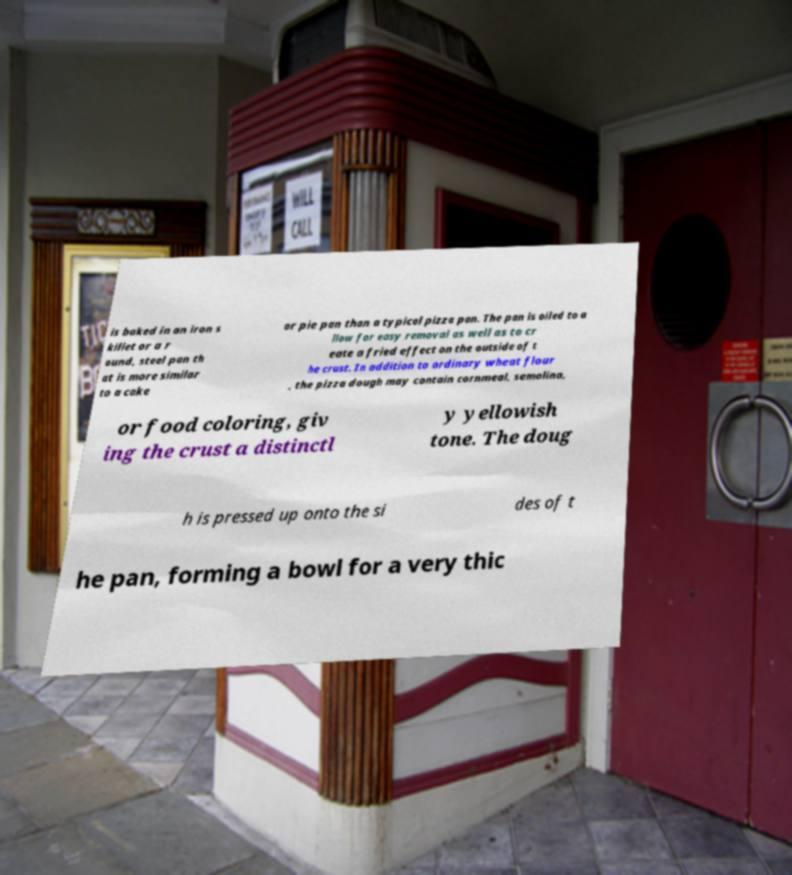Please identify and transcribe the text found in this image. is baked in an iron s killet or a r ound, steel pan th at is more similar to a cake or pie pan than a typical pizza pan. The pan is oiled to a llow for easy removal as well as to cr eate a fried effect on the outside of t he crust. In addition to ordinary wheat flour , the pizza dough may contain cornmeal, semolina, or food coloring, giv ing the crust a distinctl y yellowish tone. The doug h is pressed up onto the si des of t he pan, forming a bowl for a very thic 